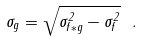<formula> <loc_0><loc_0><loc_500><loc_500>\sigma _ { g } = \sqrt { \sigma _ { f * g } ^ { 2 } - \sigma _ { f } ^ { 2 } } \ .</formula> 